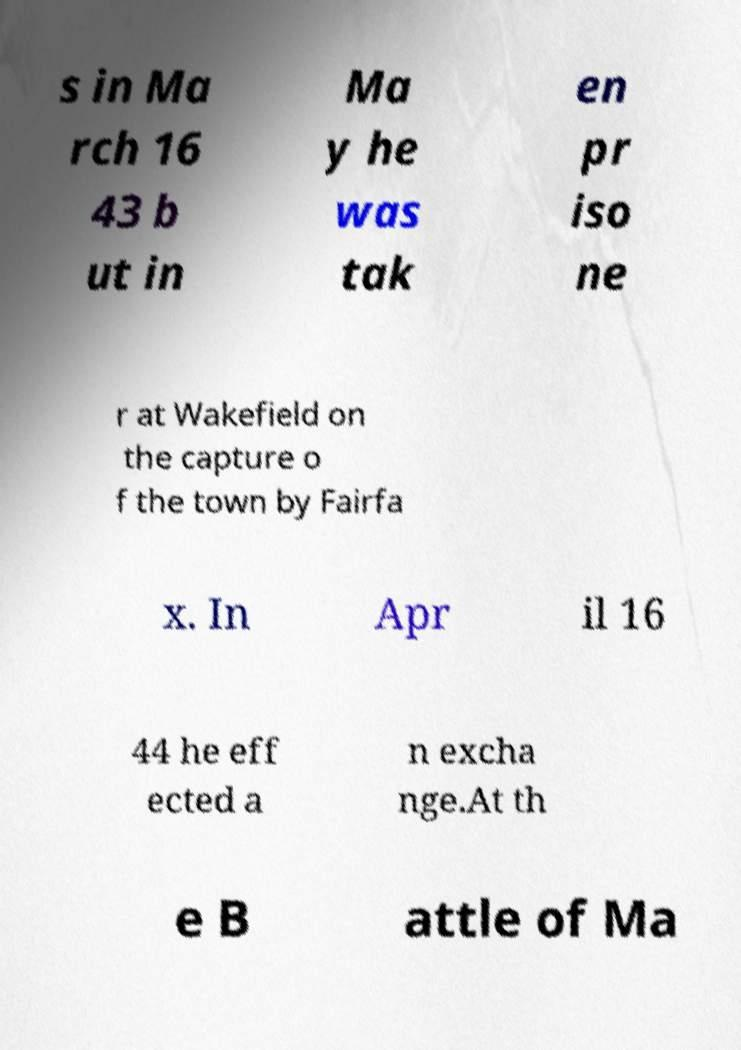Please identify and transcribe the text found in this image. s in Ma rch 16 43 b ut in Ma y he was tak en pr iso ne r at Wakefield on the capture o f the town by Fairfa x. In Apr il 16 44 he eff ected a n excha nge.At th e B attle of Ma 